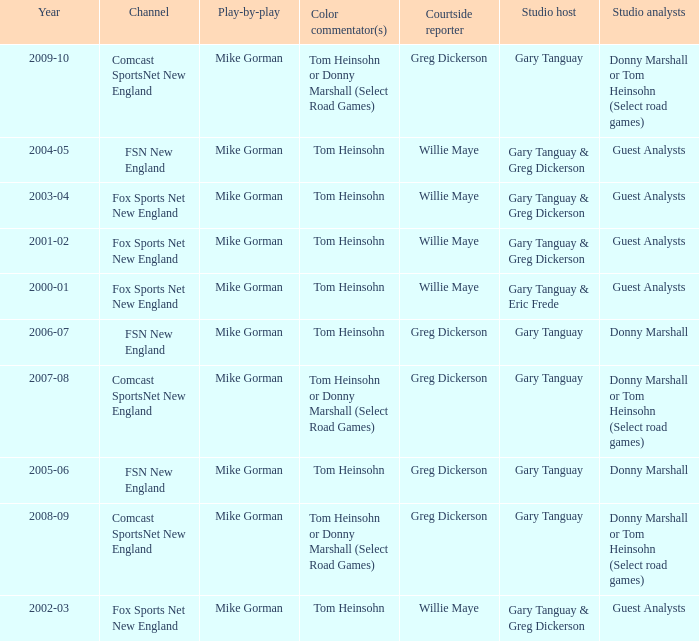WHich Studio analysts has a Studio host of gary tanguay in 2009-10? Donny Marshall or Tom Heinsohn (Select road games). 